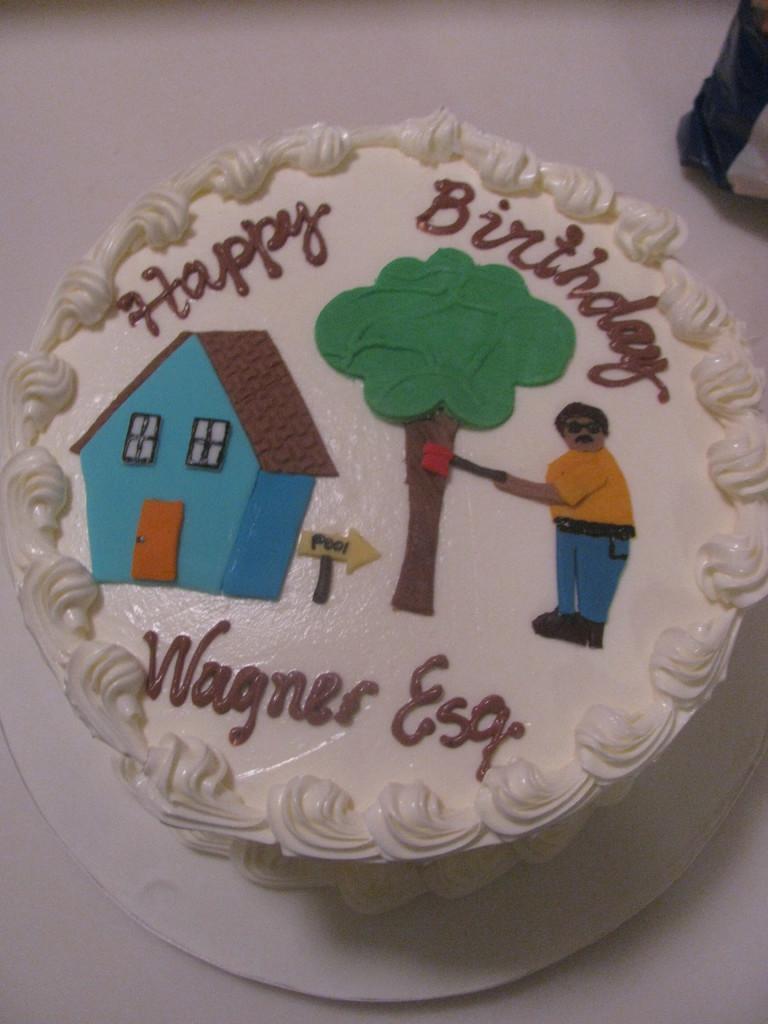Can you describe this image briefly? In this image in the center there is one cake, on the cake there is some text written and in the background there is a table. 